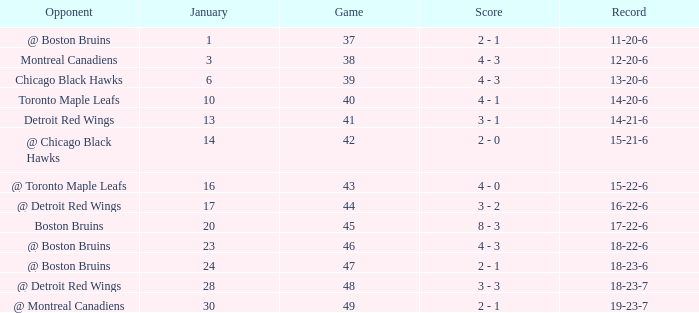What day in January was the game greater than 49 and had @ Montreal Canadiens as opponents? None. 